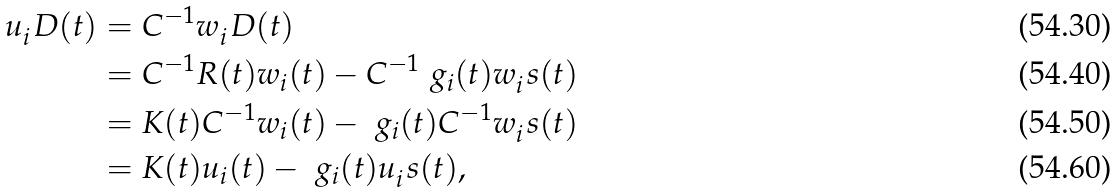Convert formula to latex. <formula><loc_0><loc_0><loc_500><loc_500>u _ { i } ^ { \ } D ( t ) & = C ^ { - 1 } w _ { i } ^ { \ } D ( t ) \\ & = C ^ { - 1 } R ( t ) w _ { i } ( t ) - C ^ { - 1 } \ g _ { i } ( t ) w _ { i } ^ { \ } s ( t ) \\ & = K ( t ) C ^ { - 1 } w _ { i } ( t ) - \ g _ { i } ( t ) C ^ { - 1 } w _ { i } ^ { \ } s ( t ) \\ & = K ( t ) u _ { i } ( t ) - \ g _ { i } ( t ) u _ { i } ^ { \ } s ( t ) ,</formula> 